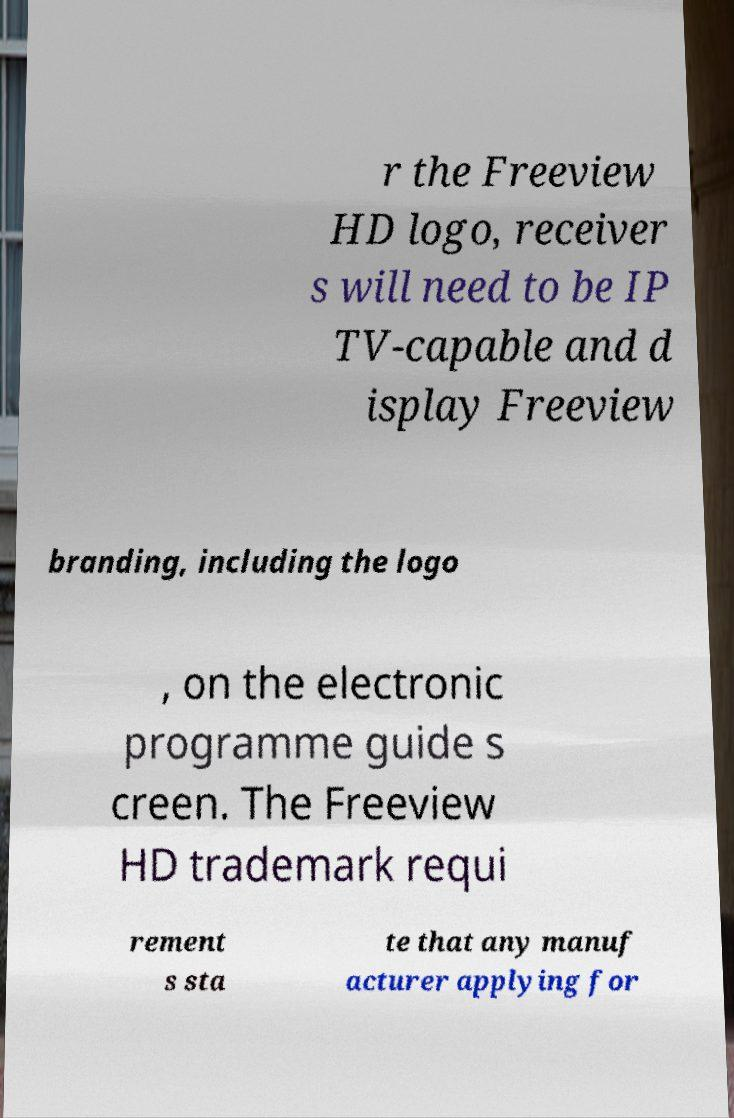I need the written content from this picture converted into text. Can you do that? r the Freeview HD logo, receiver s will need to be IP TV-capable and d isplay Freeview branding, including the logo , on the electronic programme guide s creen. The Freeview HD trademark requi rement s sta te that any manuf acturer applying for 